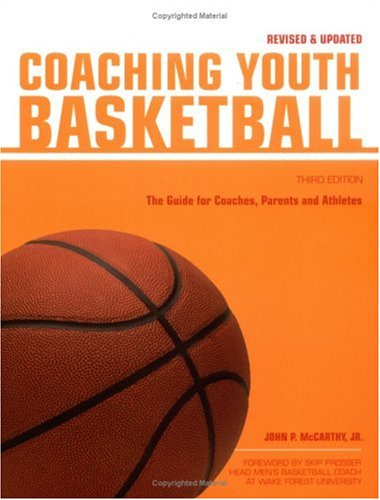What type of book is this? This is a 'Sports & Outdoors' book specifically aimed at providing guidance for coaching youth basketball, a valuable resource for coaches and parents alike. 